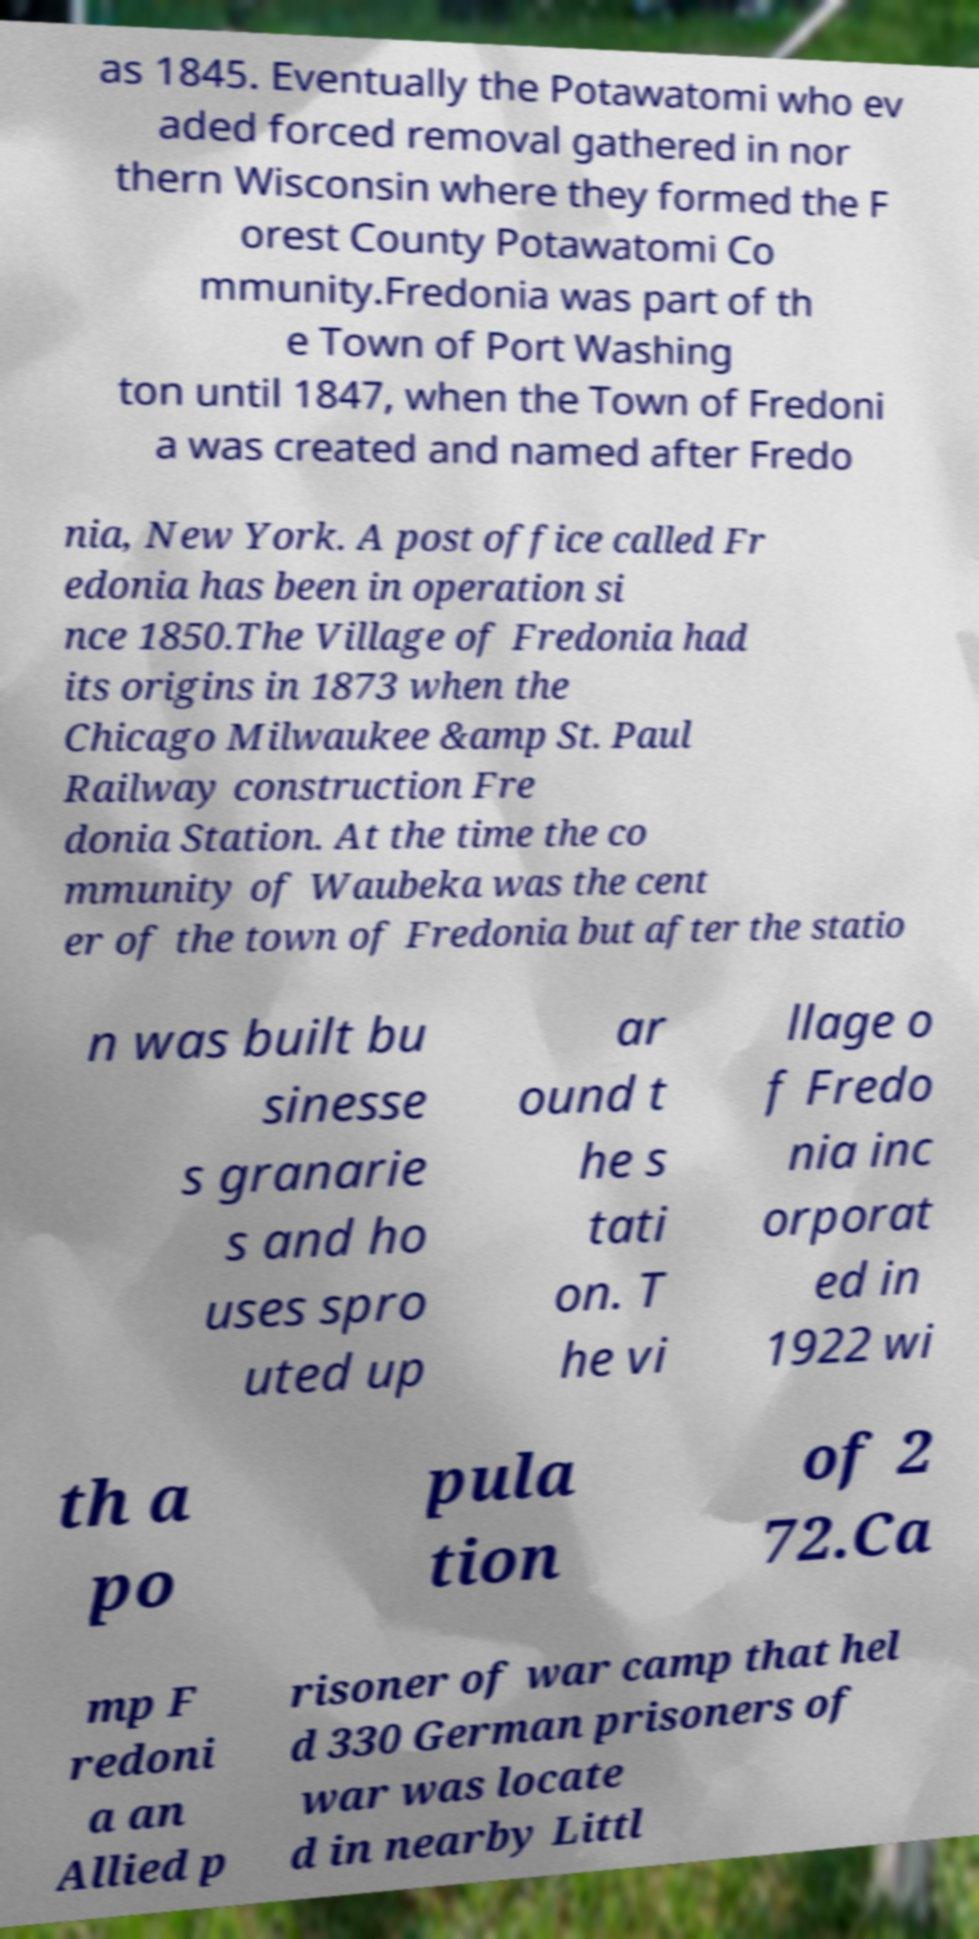What messages or text are displayed in this image? I need them in a readable, typed format. as 1845. Eventually the Potawatomi who ev aded forced removal gathered in nor thern Wisconsin where they formed the F orest County Potawatomi Co mmunity.Fredonia was part of th e Town of Port Washing ton until 1847, when the Town of Fredoni a was created and named after Fredo nia, New York. A post office called Fr edonia has been in operation si nce 1850.The Village of Fredonia had its origins in 1873 when the Chicago Milwaukee &amp St. Paul Railway construction Fre donia Station. At the time the co mmunity of Waubeka was the cent er of the town of Fredonia but after the statio n was built bu sinesse s granarie s and ho uses spro uted up ar ound t he s tati on. T he vi llage o f Fredo nia inc orporat ed in 1922 wi th a po pula tion of 2 72.Ca mp F redoni a an Allied p risoner of war camp that hel d 330 German prisoners of war was locate d in nearby Littl 